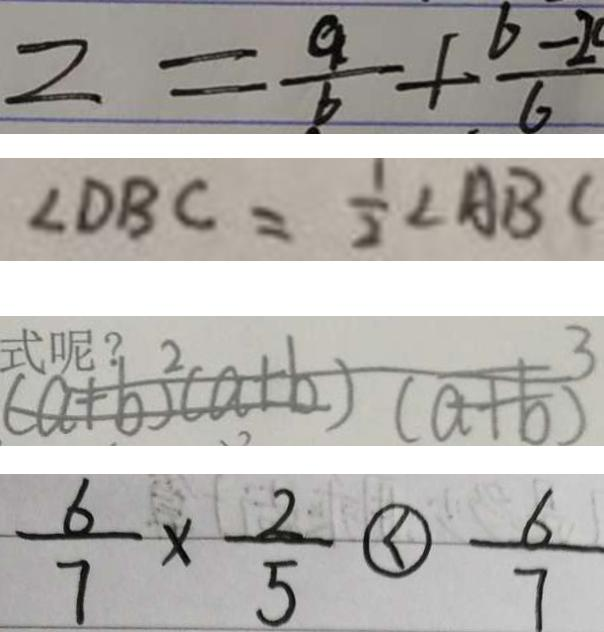<formula> <loc_0><loc_0><loc_500><loc_500>z = \frac { a } { b } + \frac { b - 2 } { 6 } 
 \angle D B C = \frac { 1 } { 2 } \angle A B C 
 ( a + b ) ^ { 2 } ( a + b ) ( a + b ) ^ { 3 } 
 \frac { 6 } { 7 } \times \frac { 2 } { 5 } \textcircled { < } \frac { 6 } { 7 }</formula> 